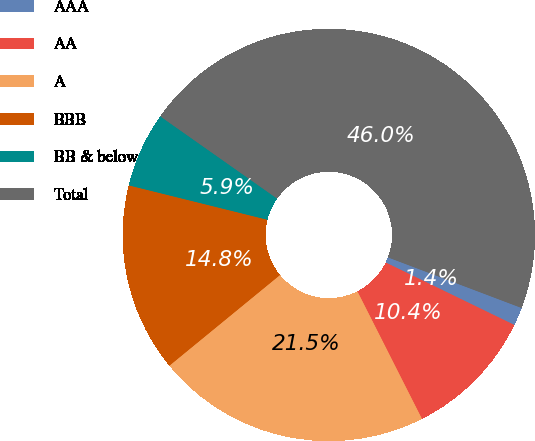Convert chart. <chart><loc_0><loc_0><loc_500><loc_500><pie_chart><fcel>AAA<fcel>AA<fcel>A<fcel>BBB<fcel>BB & below<fcel>Total<nl><fcel>1.43%<fcel>10.35%<fcel>21.53%<fcel>14.8%<fcel>5.89%<fcel>46.0%<nl></chart> 